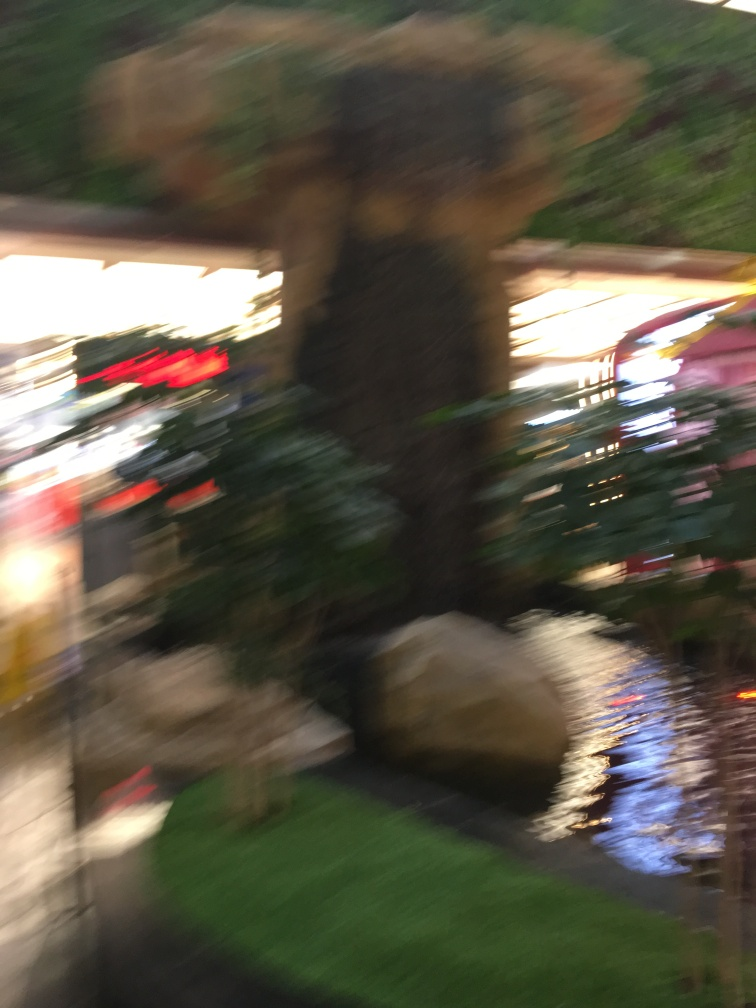What elements can you identify in this blurry image? Despite the motion blur, it's possible to make out a nature-like setting with greenery, which could be plants, and a structure that might be a waterfall or fountain, suggested by what appears to be cascading shapes and reflective surfaces that imply water. 